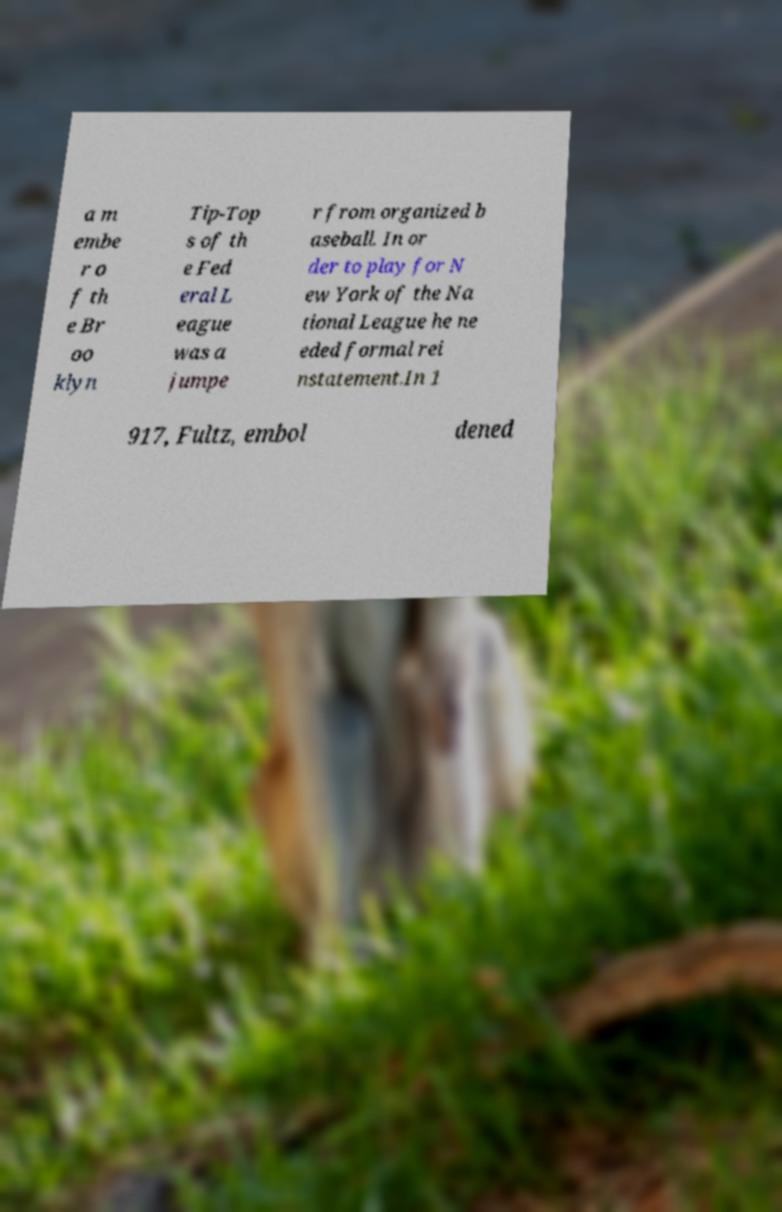Please read and relay the text visible in this image. What does it say? a m embe r o f th e Br oo klyn Tip-Top s of th e Fed eral L eague was a jumpe r from organized b aseball. In or der to play for N ew York of the Na tional League he ne eded formal rei nstatement.In 1 917, Fultz, embol dened 